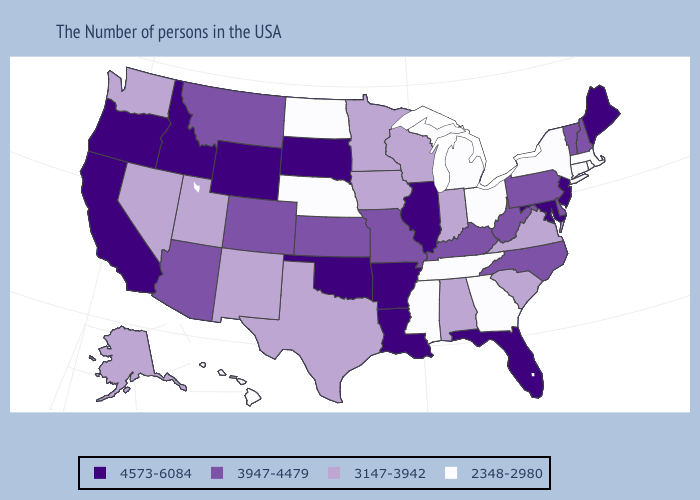How many symbols are there in the legend?
Keep it brief. 4. What is the value of North Dakota?
Be succinct. 2348-2980. What is the lowest value in the Northeast?
Give a very brief answer. 2348-2980. Name the states that have a value in the range 4573-6084?
Answer briefly. Maine, New Jersey, Maryland, Florida, Illinois, Louisiana, Arkansas, Oklahoma, South Dakota, Wyoming, Idaho, California, Oregon. Which states have the lowest value in the South?
Short answer required. Georgia, Tennessee, Mississippi. Which states hav the highest value in the Northeast?
Short answer required. Maine, New Jersey. Name the states that have a value in the range 3947-4479?
Keep it brief. New Hampshire, Vermont, Delaware, Pennsylvania, North Carolina, West Virginia, Kentucky, Missouri, Kansas, Colorado, Montana, Arizona. Does the map have missing data?
Be succinct. No. What is the value of West Virginia?
Write a very short answer. 3947-4479. Name the states that have a value in the range 3147-3942?
Keep it brief. Virginia, South Carolina, Indiana, Alabama, Wisconsin, Minnesota, Iowa, Texas, New Mexico, Utah, Nevada, Washington, Alaska. What is the value of Wyoming?
Answer briefly. 4573-6084. What is the value of Nevada?
Quick response, please. 3147-3942. Name the states that have a value in the range 3147-3942?
Concise answer only. Virginia, South Carolina, Indiana, Alabama, Wisconsin, Minnesota, Iowa, Texas, New Mexico, Utah, Nevada, Washington, Alaska. Does the first symbol in the legend represent the smallest category?
Give a very brief answer. No. 